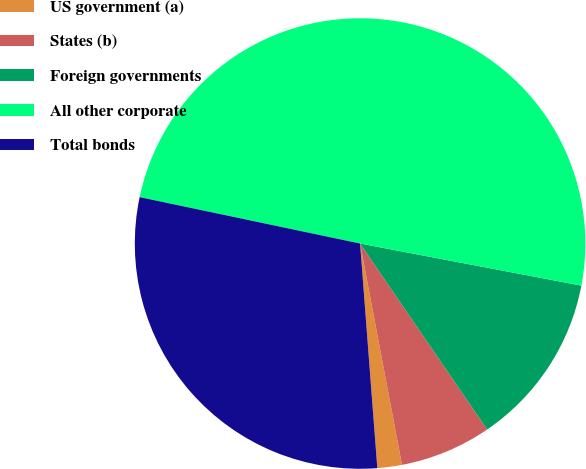Convert chart. <chart><loc_0><loc_0><loc_500><loc_500><pie_chart><fcel>US government (a)<fcel>States (b)<fcel>Foreign governments<fcel>All other corporate<fcel>Total bonds<nl><fcel>1.76%<fcel>6.56%<fcel>12.47%<fcel>49.69%<fcel>29.52%<nl></chart> 